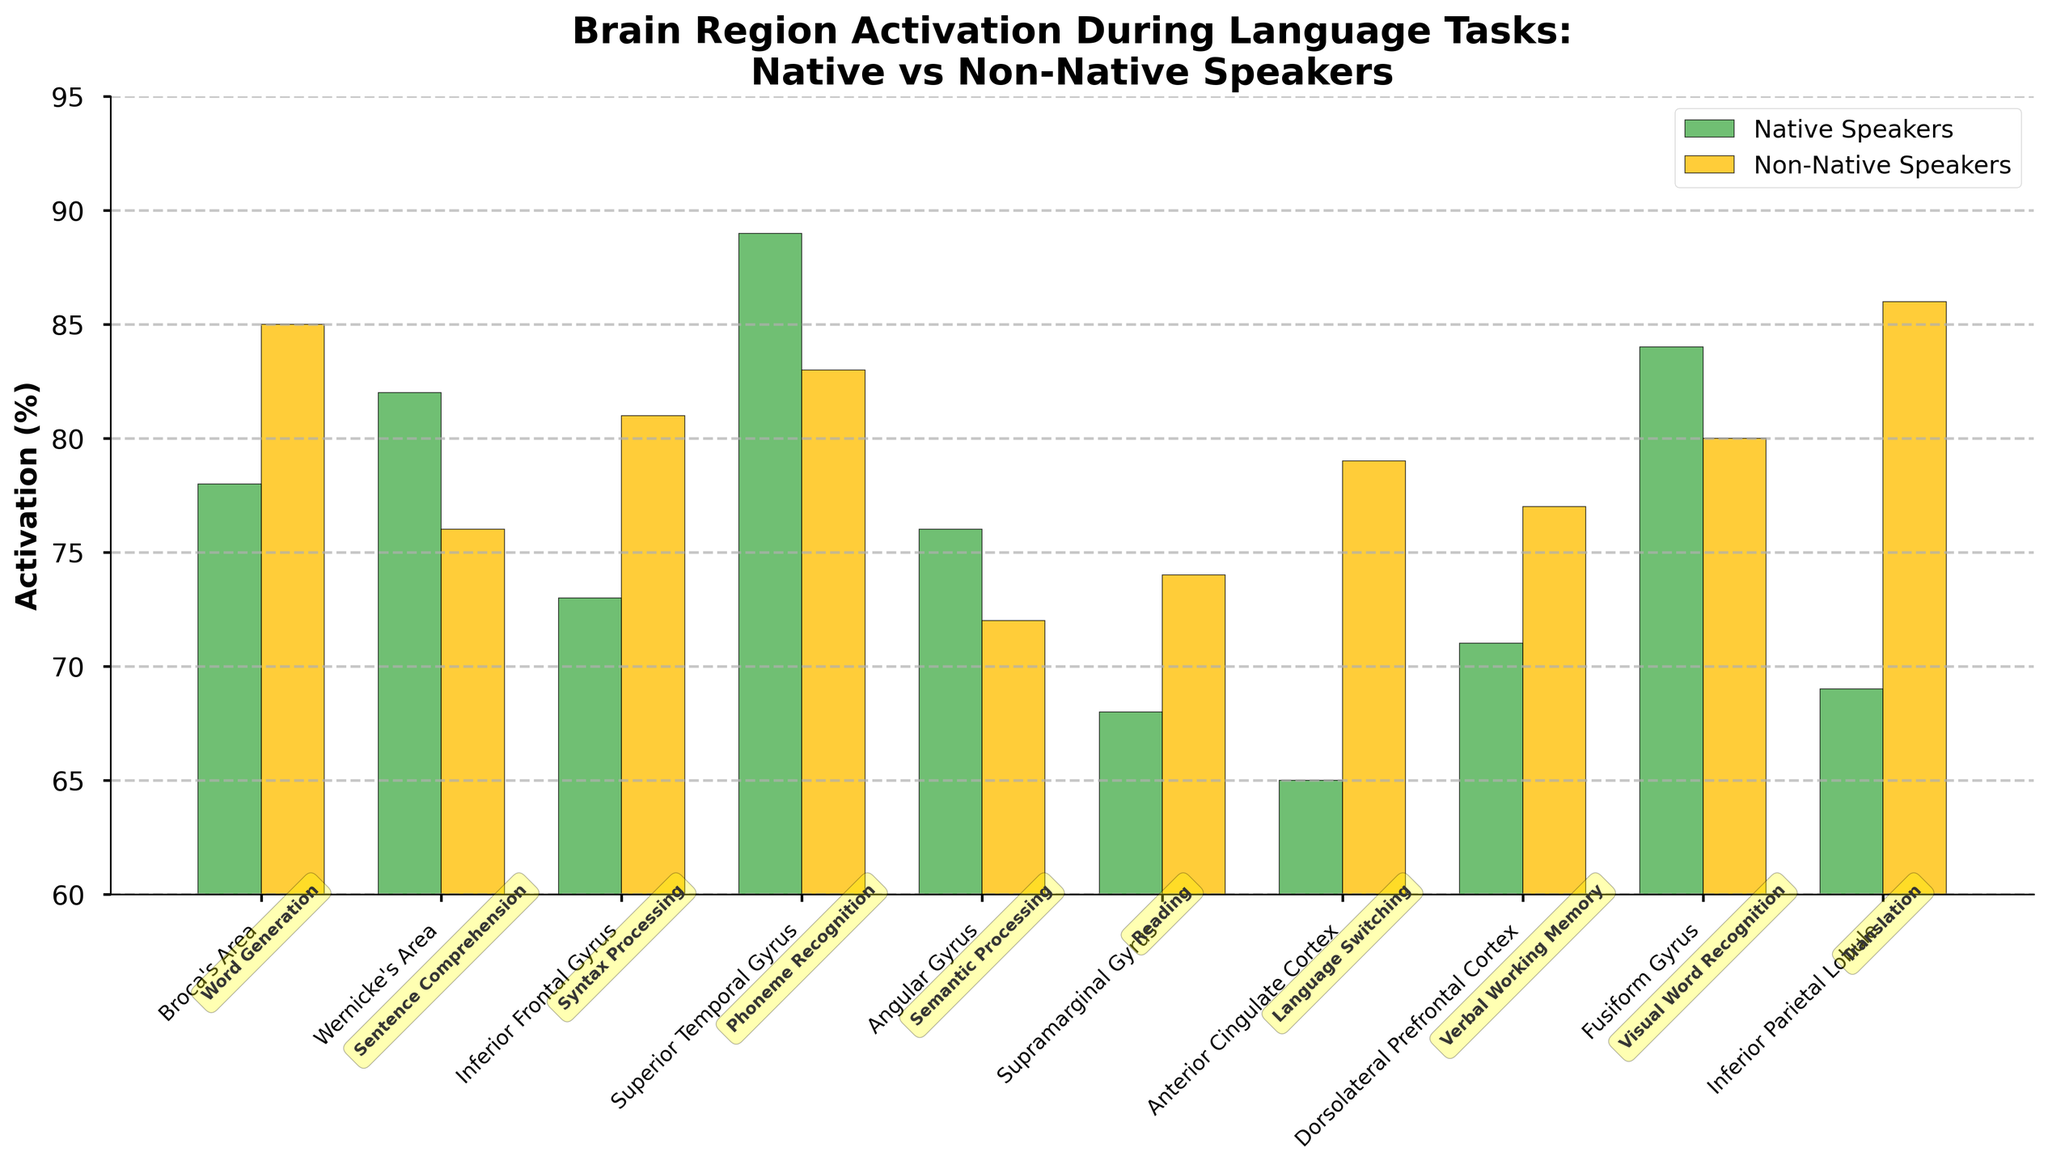Which brain region shows the highest activation for native speakers? By inspecting the bar heights for native speakers, the Superior Temporal Gyrus has the tallest bar, indicating the highest activation at 89%.
Answer: Superior Temporal Gyrus Which brain region has the largest difference in activation between native and non-native speakers? Calculate the differences in activation for each brain region. The largest difference is observed in the Inferior Parietal Lobule with a difference of 86% - 69% = 17%.
Answer: Inferior Parietal Lobule Do native speakers show higher activation than non-native speakers in Broca's Area? Compare the height of the bars for Broca's Area. Native speakers have an activation of 78%, while non-native speakers have an activation of 85%, making the latter higher.
Answer: No On average, is the activation of Inferior Frontal Gyrus higher for native speakers or non-native speakers? Compare the activations: Native speakers have 73%, while non-native speakers have 81%. The average is higher for non-native speakers.
Answer: Non-native speakers Which task shows the greatest activation for native speakers in the Anterior Cingulate Cortex? Identify the bar for the Anterior Cingulate Cortex and observe the activation percentage for native speakers, it is 65% which corresponds to the Language Switching task.
Answer: Language Switching What is the average activation in the Angular Gyrus for both groups? Calculate the average: (76% + 72%) / 2 = 74%.
Answer: 74% Is there any brain region where native speakers have equal activation to non-native speakers? By visually inspecting the bars, there is no brain region where both native and non-native speakers have equal activation; all have differing heights.
Answer: No Which brain region associated with language shows the least activation overall? Identify the shortest bars for both groups. The Supramarginal Gyrus has the lowest overall activation, with 68% for native speakers and 74% for non-native speakers, which are comparatively low among all regions.
Answer: Supramarginal Gyrus Which task shows higher activation for non-native speakers in the Dorsolateral Prefrontal Cortex? Check the bar for the Dorsolateral Prefrontal Cortex, and observe the non-native speakers' activation at 77%, which corresponds to the Verbal Working Memory task.
Answer: Verbal Working Memory 